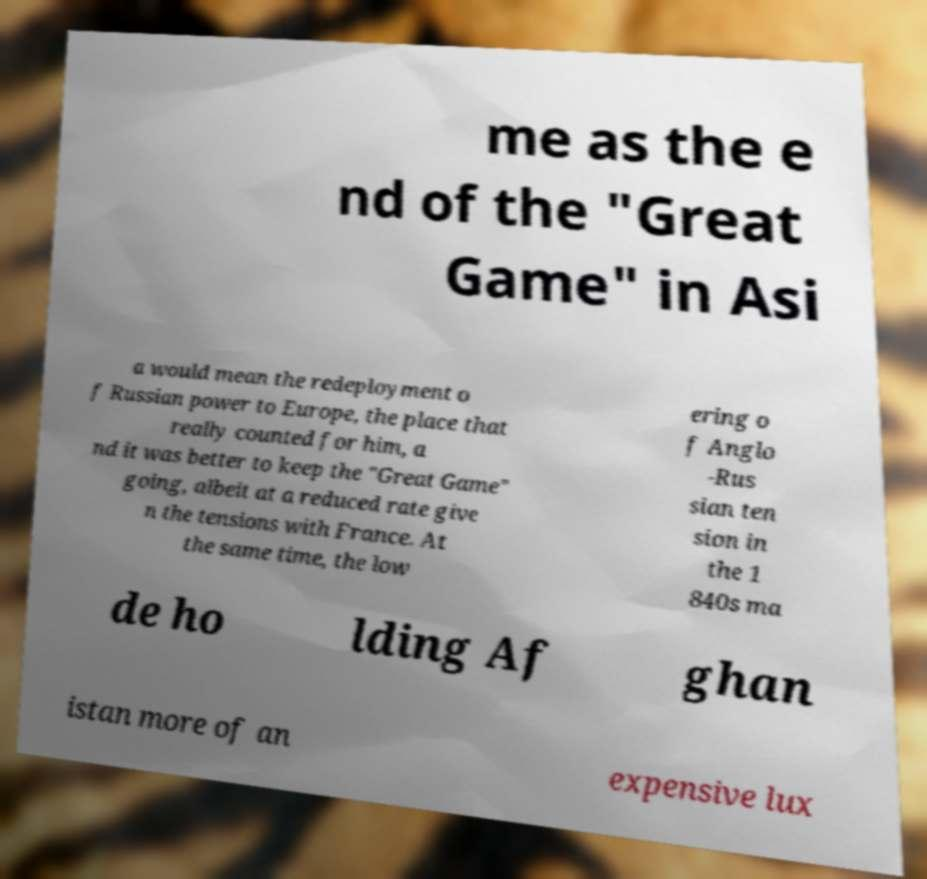Can you read and provide the text displayed in the image?This photo seems to have some interesting text. Can you extract and type it out for me? me as the e nd of the "Great Game" in Asi a would mean the redeployment o f Russian power to Europe, the place that really counted for him, a nd it was better to keep the "Great Game" going, albeit at a reduced rate give n the tensions with France. At the same time, the low ering o f Anglo -Rus sian ten sion in the 1 840s ma de ho lding Af ghan istan more of an expensive lux 